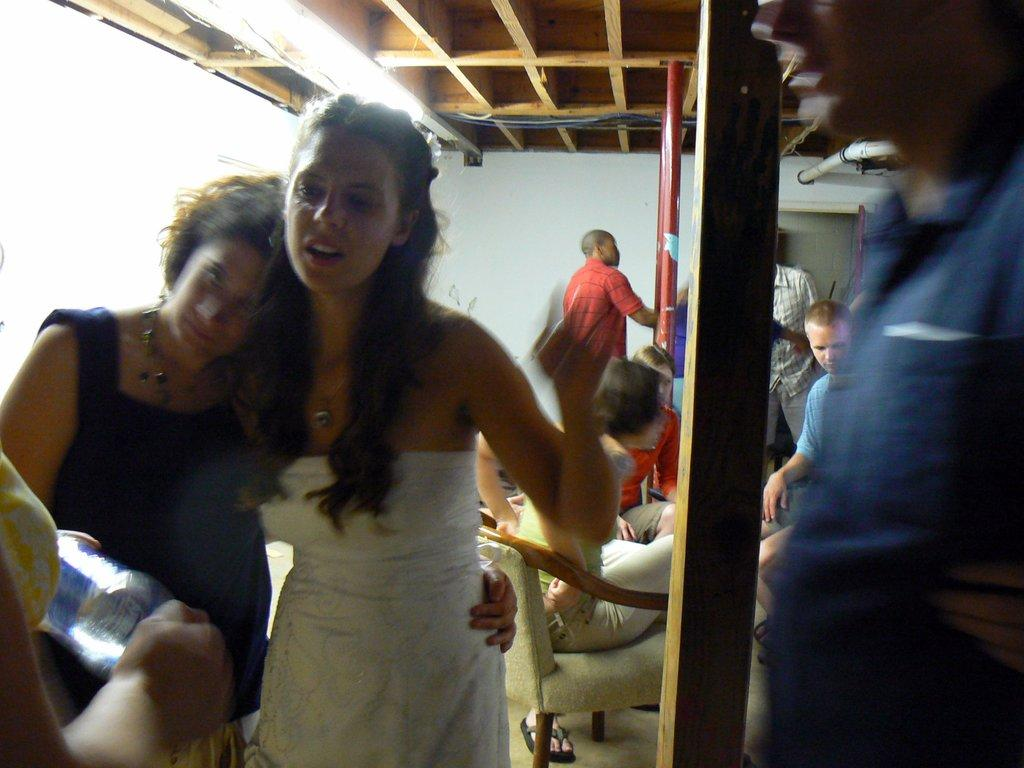What are the people in the room doing? The people in the room are sitting and standing. What can be seen on the ceiling of the room? There are lights on the ceiling. How many bikes are parked inside the room? There is no mention of bikes in the image, so it cannot be determined how many bikes are present. 